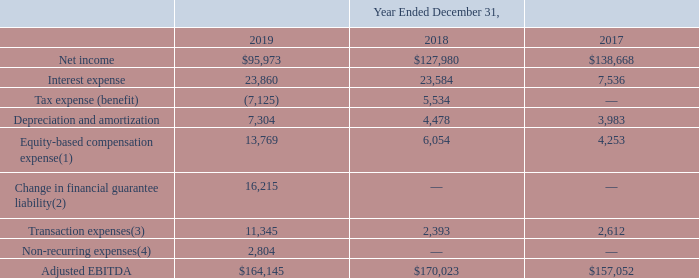ITEM 7. MANAGEMENT'S DISCUSSION AND ANALYSIS OF FINANCIAL CONDITION AND RESULTS OF OPERATIONS (United States Dollars in thousands, except per share data and unless otherwise indicated)
Adjusted EBITDA has limitations as an analytical tool and should not be considered in isolation from, or as a substitute for, the analysis of other GAAP financial measures, such as net income. Some of the limitations of Adjusted EBITDA include:
• It does not reflect our current contractual commitments that will have an impact on future cash flows; • It does not reflect the impact of working capital requirements or capital expenditures; and • It is not a universally consistent calculation, which limits its usefulness as a comparative measure.
Management compensates for the inherent limitations associated with using the measure of Adjusted EBITDA through disclosure of such limitations, presentation of our financial statements in accordance with GAAP and reconciliation of Adjusted EBITDA to the most directly comparable GAAP measure, net income, as presented below.
(1) Includes equity-based compensation to employees and directors, as well as equity-based payments to non-employees.
(2) Includes losses recorded in the fourth quarter of 2019 associated with the financial guarantee arrangement for a Bank Partner that did not renew its loan origination agreement when it expired in November 2019. See Note 14 to the Notes to Consolidated Financial Statements included in Item 8 for additional discussion of our financial guarantee arrangements.
(3) For the year ended December 31, 2019, includes loss on remeasurement of our tax receivable agreement liability of $9.8 million and professional fees associated with our strategic alternatives review process of $1.5 million. For the year ended December 31, 2018, includes certain costs associated with our IPO, which were not deferrable against the proceeds of the IPO. Further, includes certain costs, such as legal and debt arrangement costs, related to our March 2018 term loan upsizing. For the year ended December 31, 2017, includes one-time fees paid to an affiliate of one of the members of the board of managers in conjunction with the August 2017 term loan transaction.
(4) For the year ended December 31, 2019, includes (i) legal fees associated with IPO related litigation of $2.0 million, (ii) one-time tax compliance fees related to filing the final tax return for the Former Corporate Investors associated with the Reorganization Transactions of $0.2 million, and (iii) lien filing expenses related to certain Bank Partner solar loans of $0.6 million.
Which years does the table show? 2019, 2018, 2017. What was the net income in 2019?
Answer scale should be: thousand. 95,973. What was the interest expense in 2018?
Answer scale should be: thousand. 23,584. How many years did net income exceed $100,000 thousand? 2018##2017
Answer: 2. What was the change in the interest expense between 2017 and 2018?
Answer scale should be: thousand. 23,584-7,536
Answer: 16048. What was the percentage change in Depreciation and amortization between 2018 and 2019?
Answer scale should be: percent. (7,304-4,478)/4,478
Answer: 63.11. 